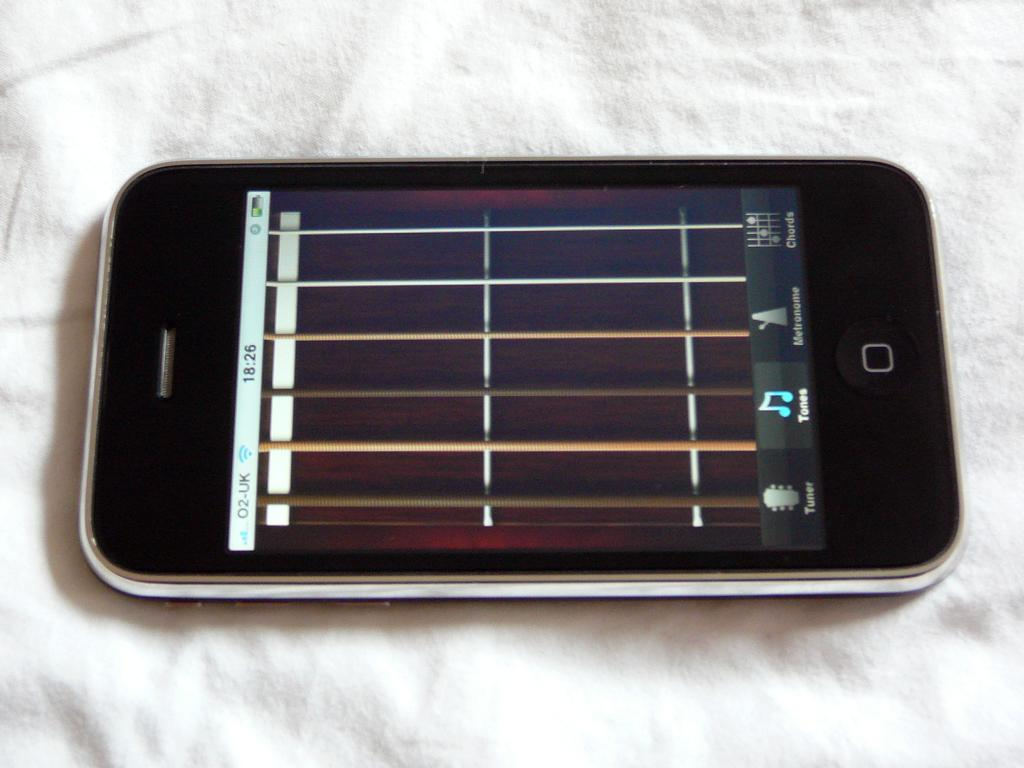<image>
Relay a brief, clear account of the picture shown. An unknown brand of electonic device that says UK in the top left corner of the screen. 